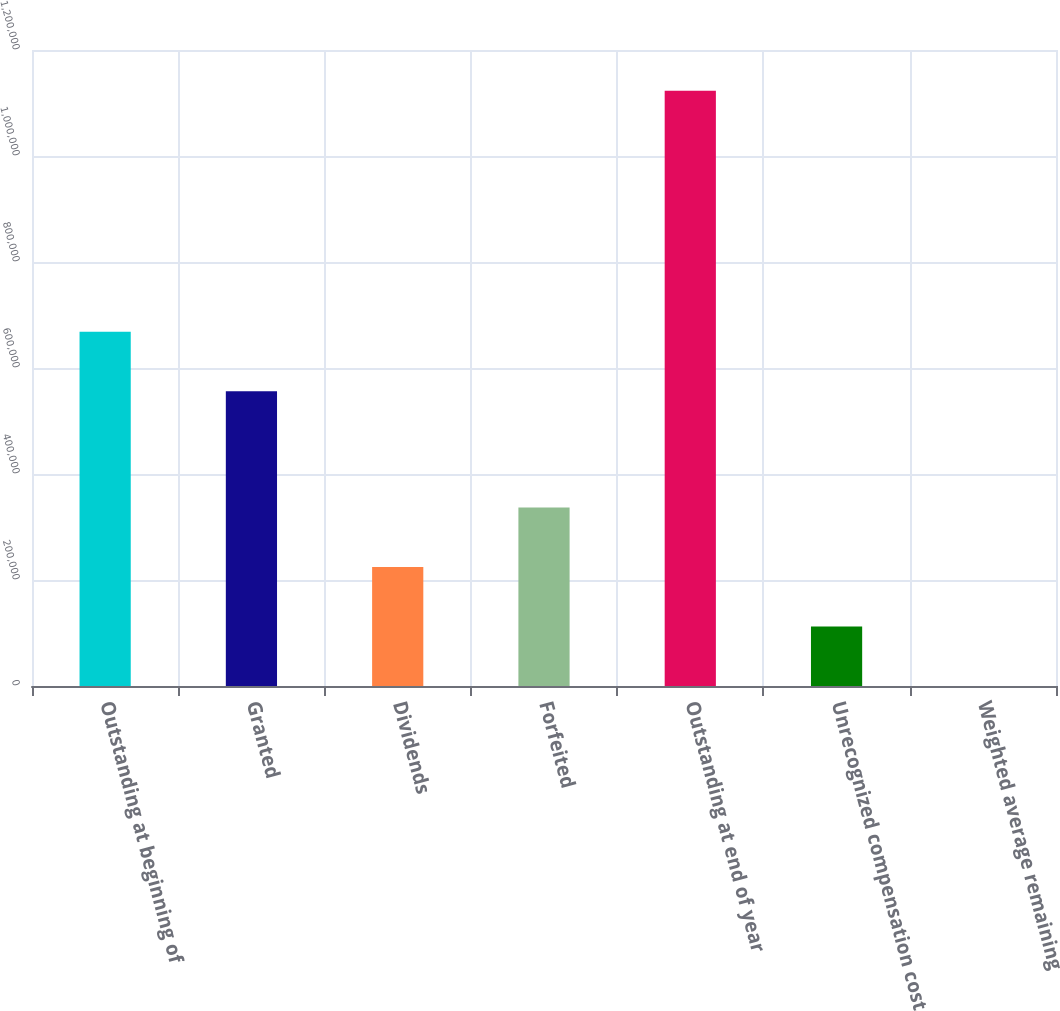Convert chart. <chart><loc_0><loc_0><loc_500><loc_500><bar_chart><fcel>Outstanding at beginning of<fcel>Granted<fcel>Dividends<fcel>Forfeited<fcel>Outstanding at end of year<fcel>Unrecognized compensation cost<fcel>Weighted average remaining<nl><fcel>668506<fcel>556203<fcel>224608<fcel>336912<fcel>1.12304e+06<fcel>112305<fcel>1.8<nl></chart> 